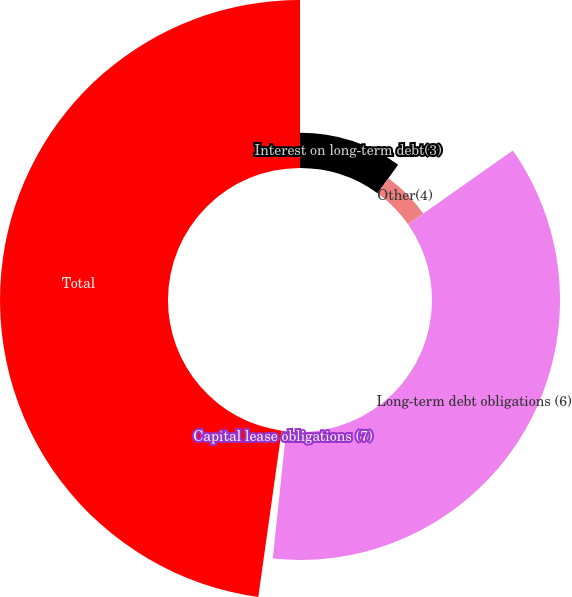Convert chart. <chart><loc_0><loc_0><loc_500><loc_500><pie_chart><fcel>Interest on long-term debt(3)<fcel>Other(4)<fcel>Long-term debt obligations (6)<fcel>Capital lease obligations (7)<fcel>Total<nl><fcel>9.99%<fcel>5.27%<fcel>36.41%<fcel>0.55%<fcel>47.78%<nl></chart> 